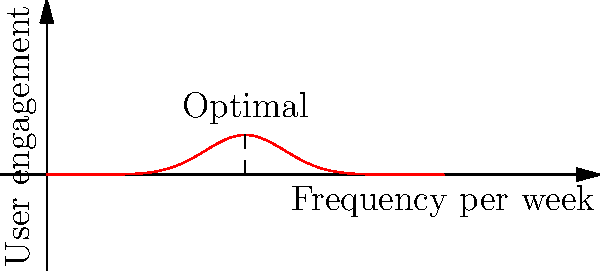Based on the bell curve distribution shown in the graph, which represents user engagement in relation to push notification frequency, what is the optimal number of push notifications to send per week to maximize user engagement? To determine the optimal number of push notifications per week, we need to analyze the bell curve distribution in the graph:

1. The x-axis represents the frequency of push notifications per week.
2. The y-axis represents user engagement.
3. The bell curve shows the relationship between notification frequency and user engagement.
4. In a normal distribution (bell curve), the peak of the curve represents the optimal point.
5. The peak of this curve is clearly visible at the center of the x-axis.
6. The x-axis is labeled from 0 to 10, with the peak occurring at the midpoint.
7. The midpoint between 0 and 10 is 5.
8. Therefore, the optimal number of push notifications per week is 5.

This frequency maximizes user engagement while avoiding overwhelming users with too many notifications or losing their interest with too few.
Answer: 5 notifications per week 